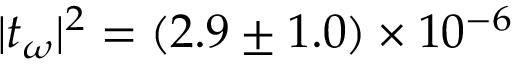Convert formula to latex. <formula><loc_0><loc_0><loc_500><loc_500>| t _ { \omega } | ^ { 2 } = ( 2 . 9 \pm 1 . 0 ) \times 1 0 ^ { - 6 }</formula> 